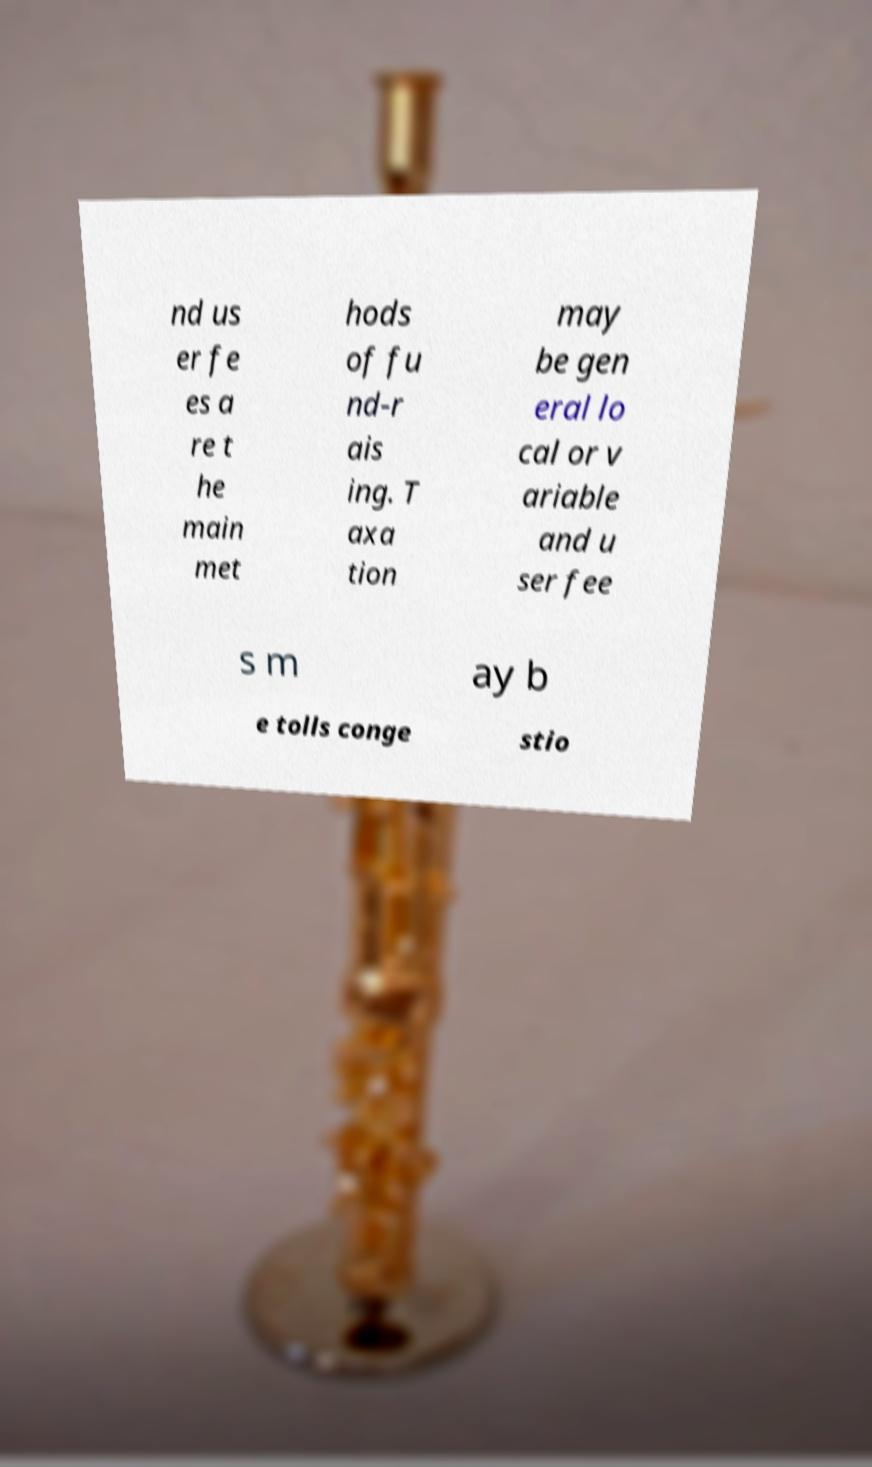Could you assist in decoding the text presented in this image and type it out clearly? nd us er fe es a re t he main met hods of fu nd-r ais ing. T axa tion may be gen eral lo cal or v ariable and u ser fee s m ay b e tolls conge stio 